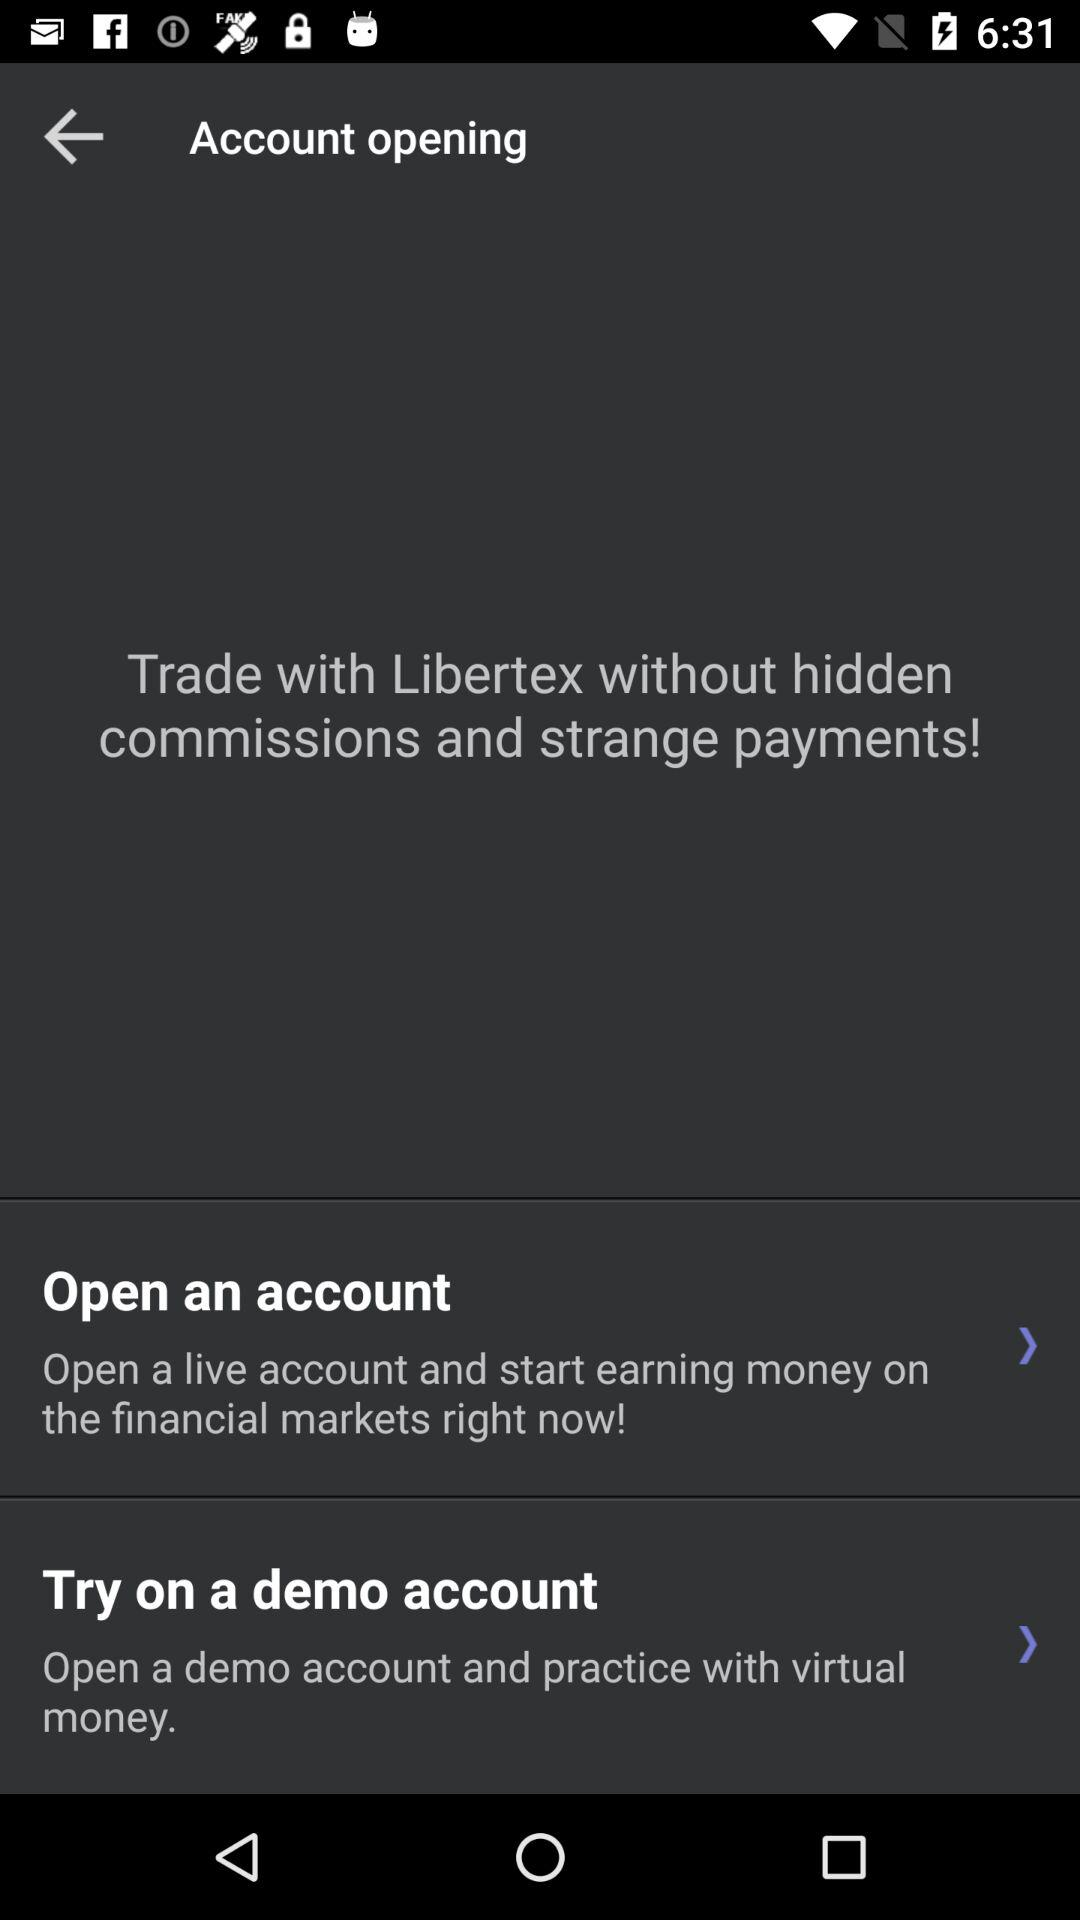How many more demo account options are there than live account options?
Answer the question using a single word or phrase. 1 